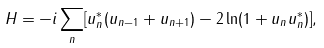Convert formula to latex. <formula><loc_0><loc_0><loc_500><loc_500>H = - i \sum _ { n } [ u _ { n } ^ { * } ( u _ { n - 1 } + u _ { n + 1 } ) - 2 \ln ( 1 + u _ { n } u _ { n } ^ { * } ) ] ,</formula> 